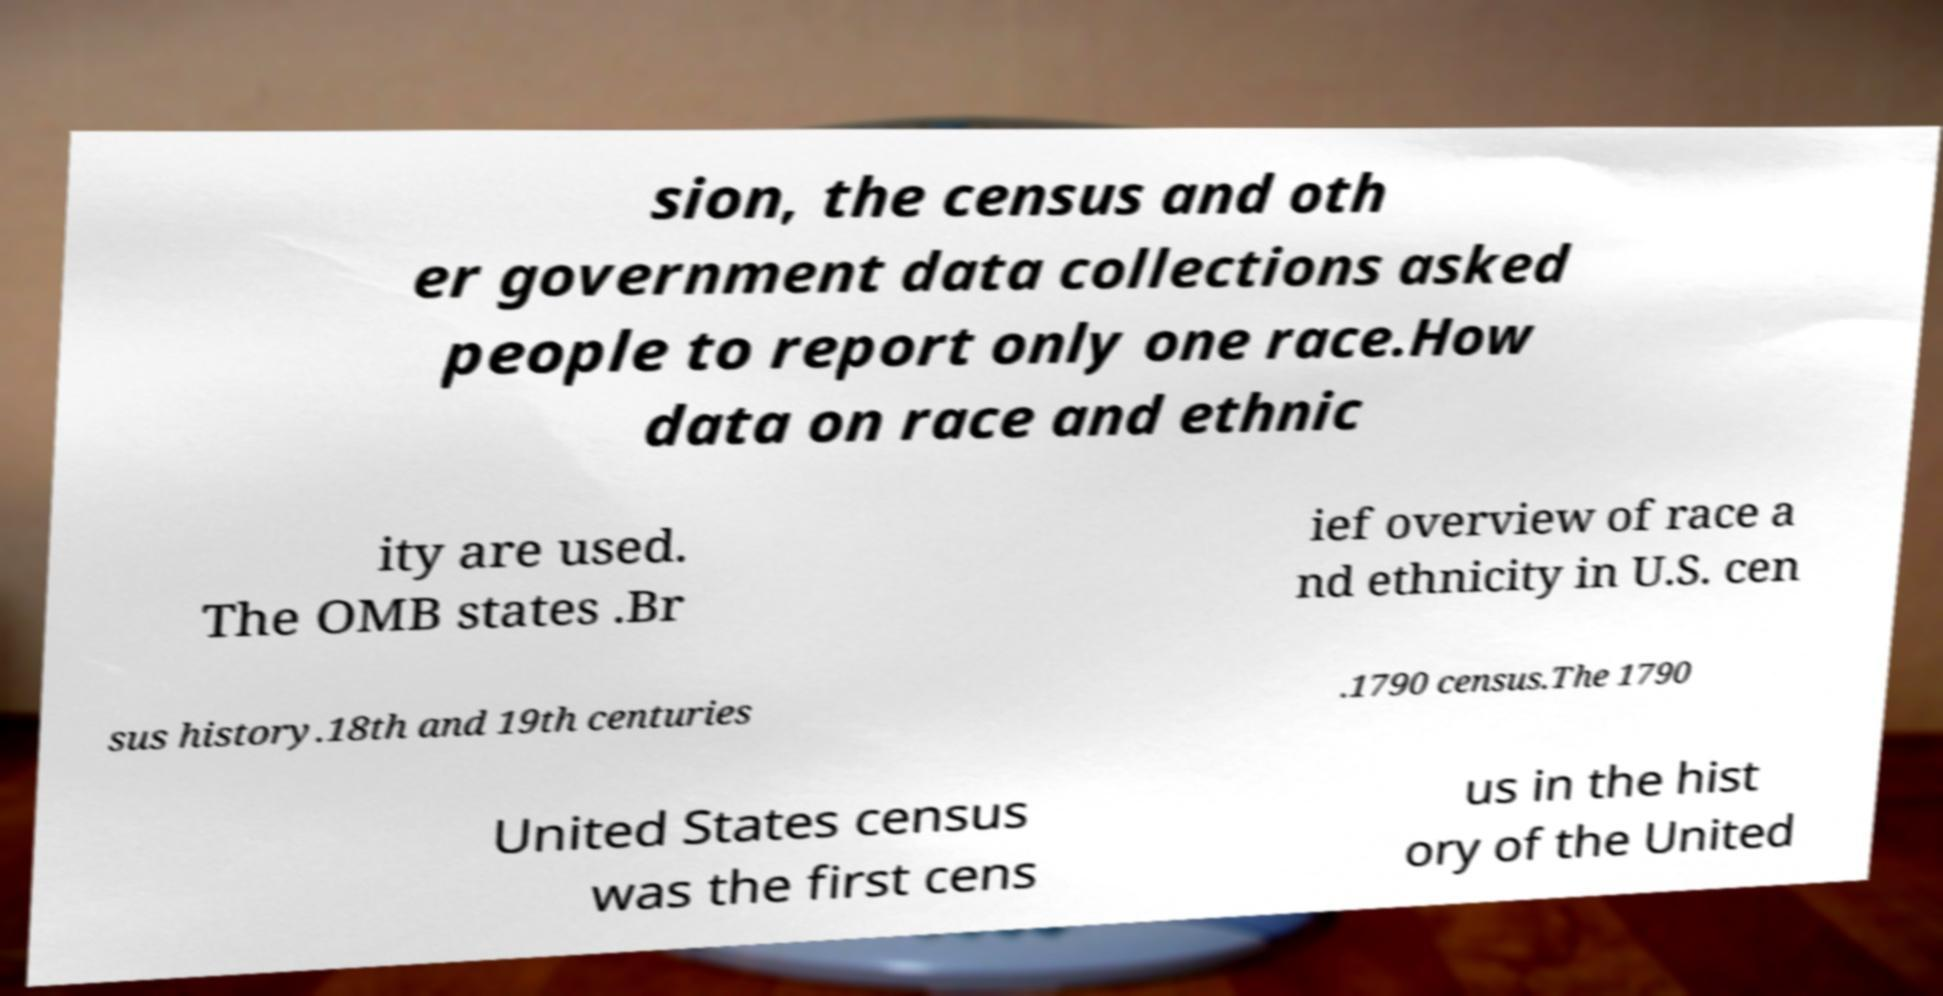I need the written content from this picture converted into text. Can you do that? sion, the census and oth er government data collections asked people to report only one race.How data on race and ethnic ity are used. The OMB states .Br ief overview of race a nd ethnicity in U.S. cen sus history.18th and 19th centuries .1790 census.The 1790 United States census was the first cens us in the hist ory of the United 